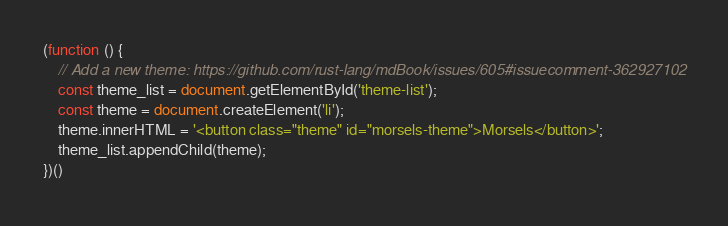Convert code to text. <code><loc_0><loc_0><loc_500><loc_500><_JavaScript_>(function () {
    // Add a new theme: https://github.com/rust-lang/mdBook/issues/605#issuecomment-362927102
    const theme_list = document.getElementById('theme-list');
    const theme = document.createElement('li');
    theme.innerHTML = '<button class="theme" id="morsels-theme">Morsels</button>';
    theme_list.appendChild(theme);
})()
</code> 